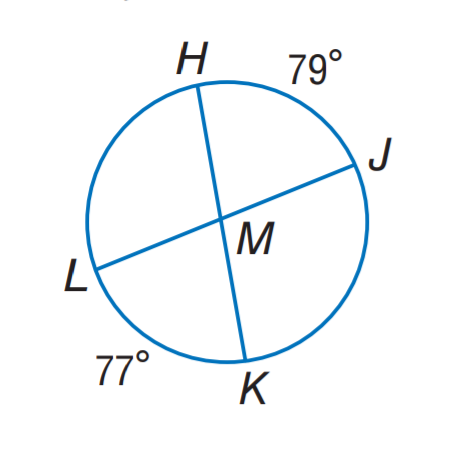Answer the mathemtical geometry problem and directly provide the correct option letter.
Question: Find m \angle J M K.
Choices: A: 79 B: 101 C: 102 D: 103 C 